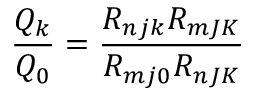<formula> <loc_0><loc_0><loc_500><loc_500>\frac { Q _ { k } } { Q _ { 0 } } = \frac { R _ { n j k } R _ { m J K } } { R _ { m j 0 } R _ { n J K } }</formula> 